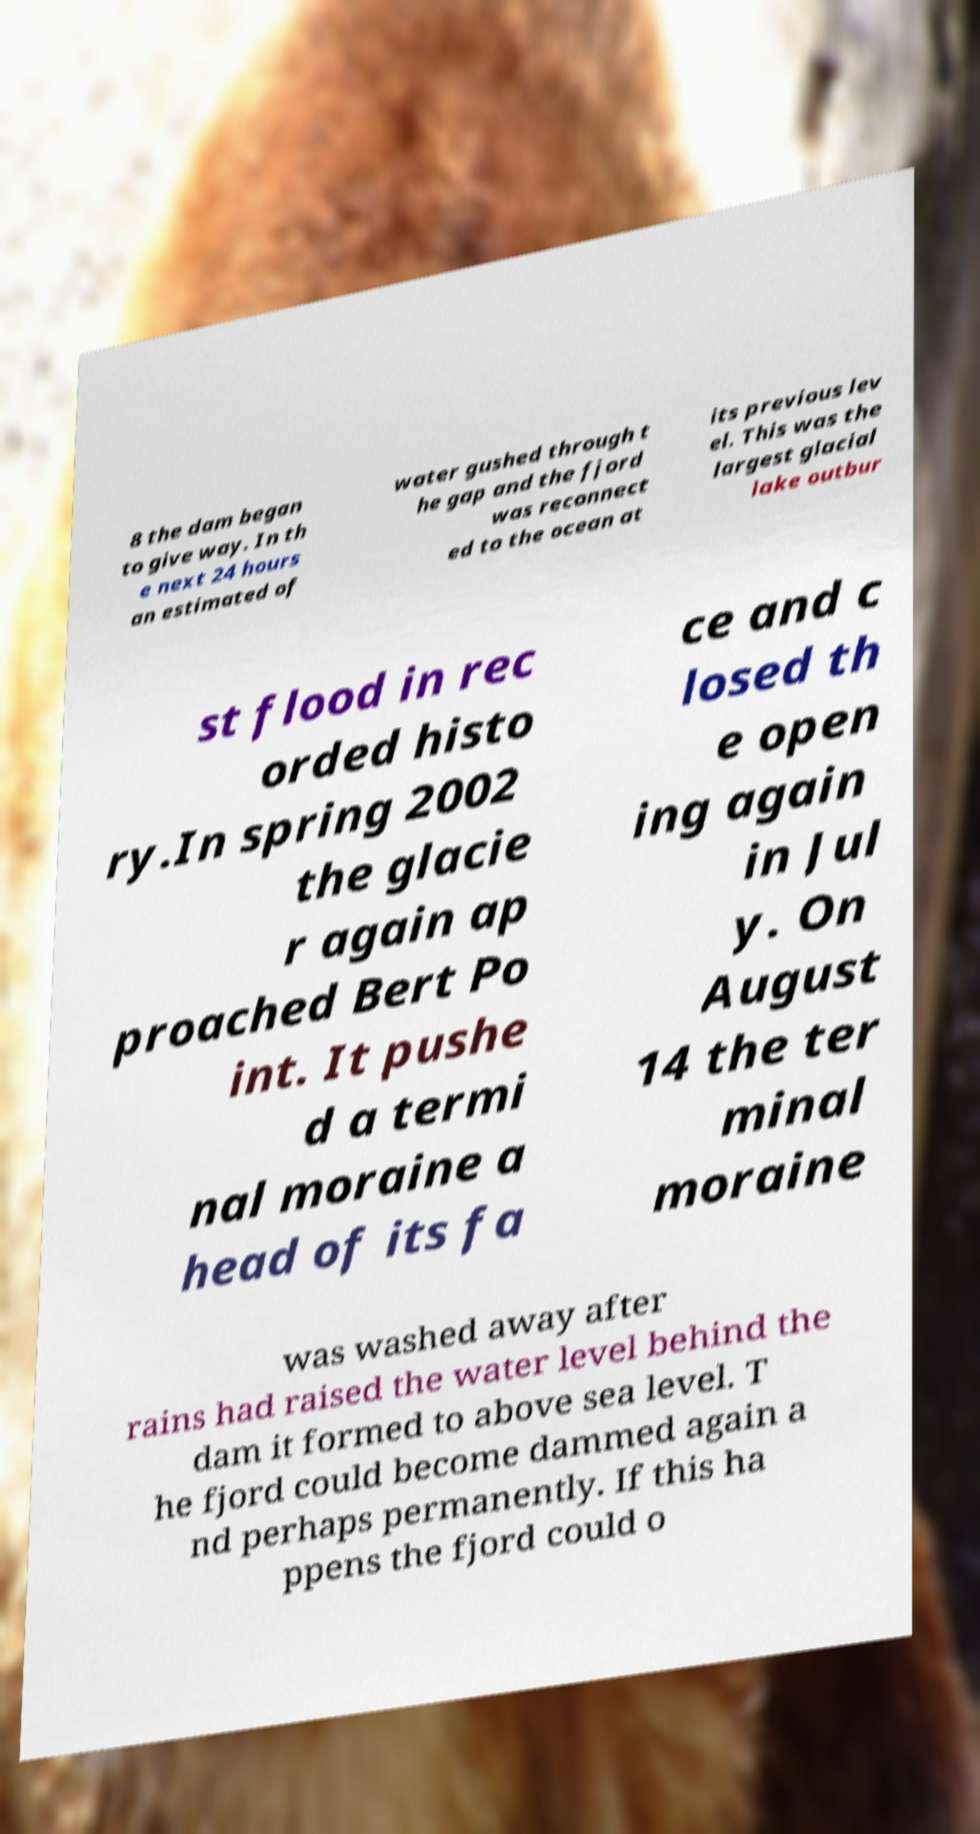There's text embedded in this image that I need extracted. Can you transcribe it verbatim? 8 the dam began to give way. In th e next 24 hours an estimated of water gushed through t he gap and the fjord was reconnect ed to the ocean at its previous lev el. This was the largest glacial lake outbur st flood in rec orded histo ry.In spring 2002 the glacie r again ap proached Bert Po int. It pushe d a termi nal moraine a head of its fa ce and c losed th e open ing again in Jul y. On August 14 the ter minal moraine was washed away after rains had raised the water level behind the dam it formed to above sea level. T he fjord could become dammed again a nd perhaps permanently. If this ha ppens the fjord could o 